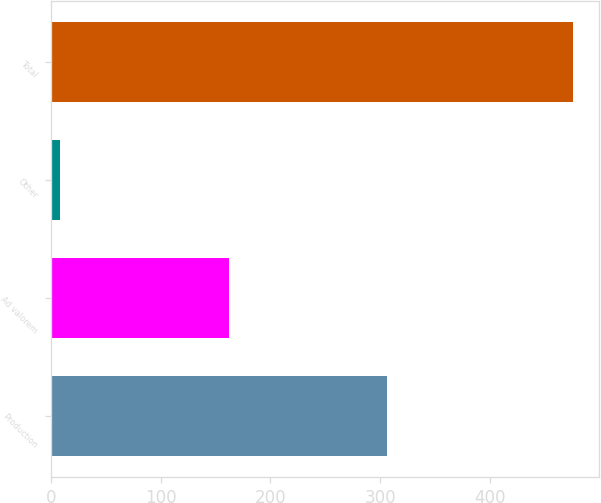Convert chart. <chart><loc_0><loc_0><loc_500><loc_500><bar_chart><fcel>Production<fcel>Ad valorem<fcel>Other<fcel>Total<nl><fcel>306<fcel>162<fcel>8<fcel>476<nl></chart> 